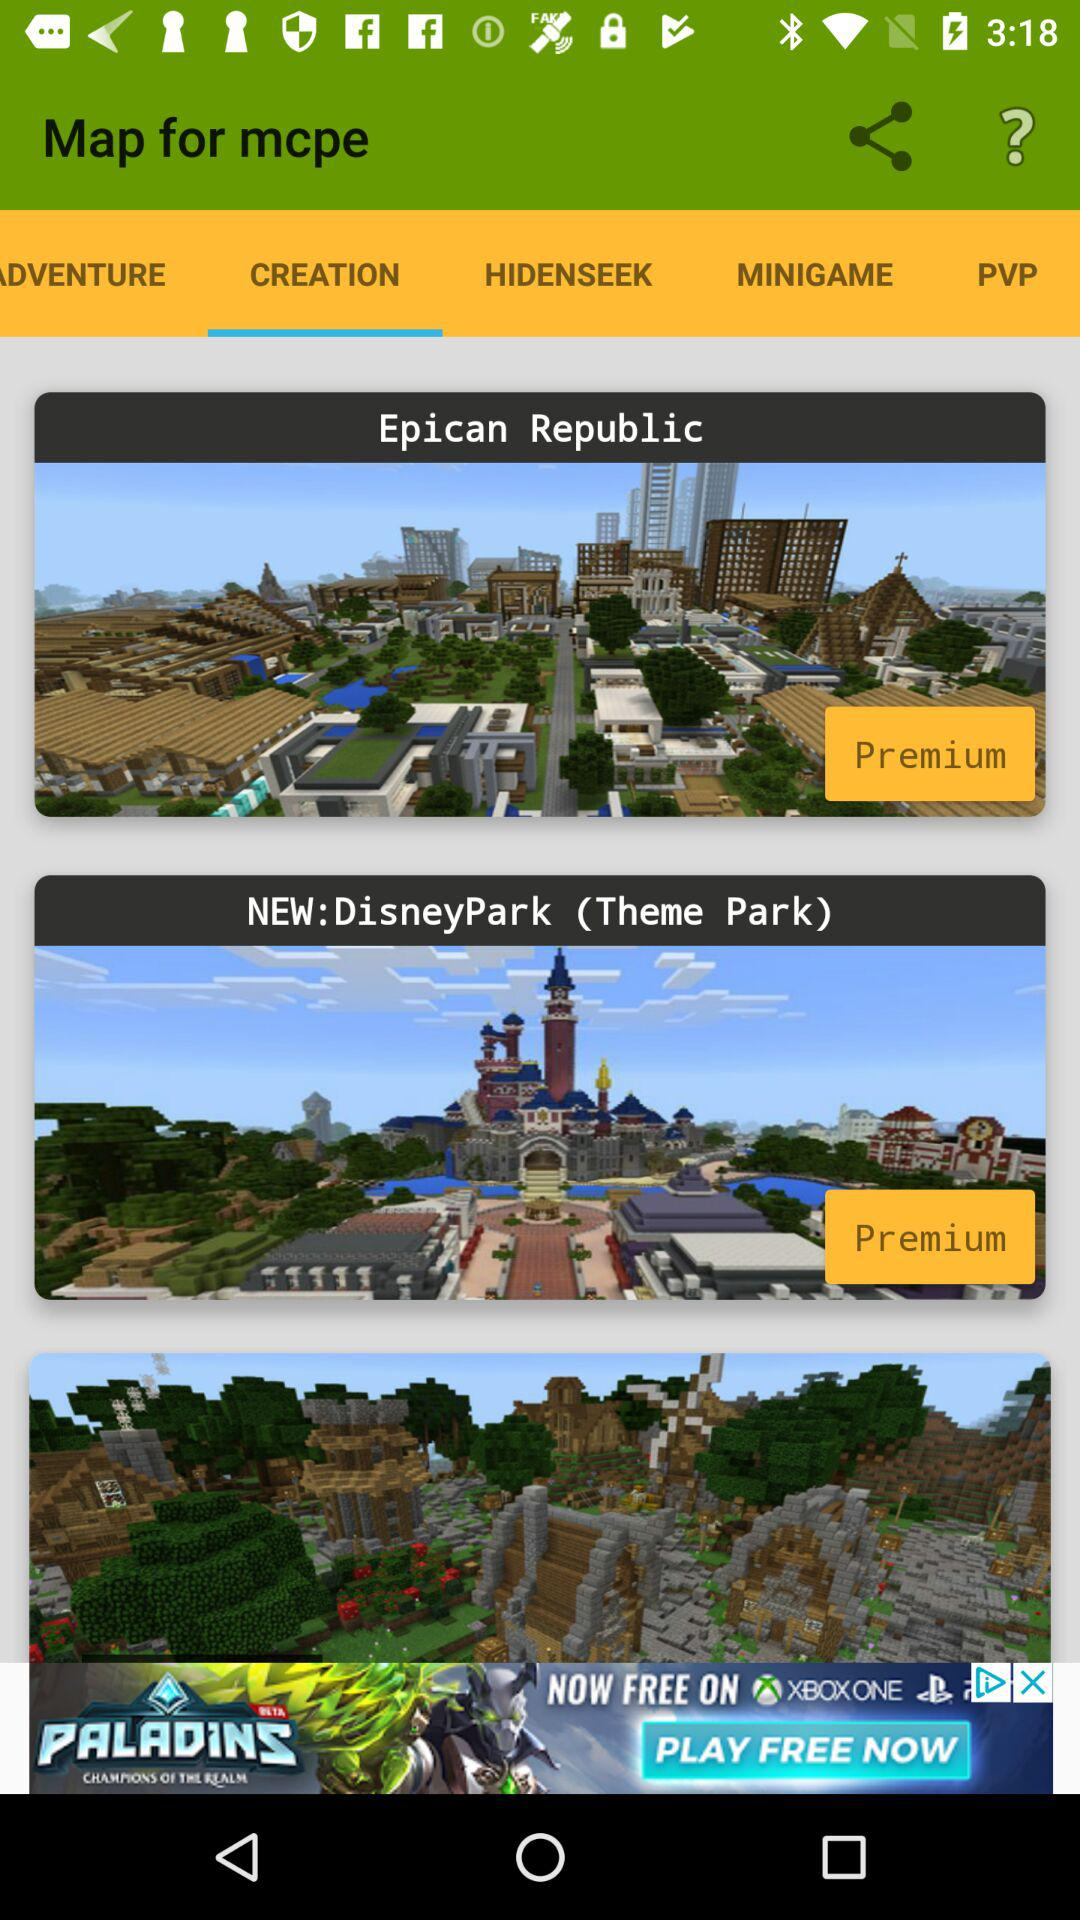Which tab is selected? The selected tab is "CREATION". 